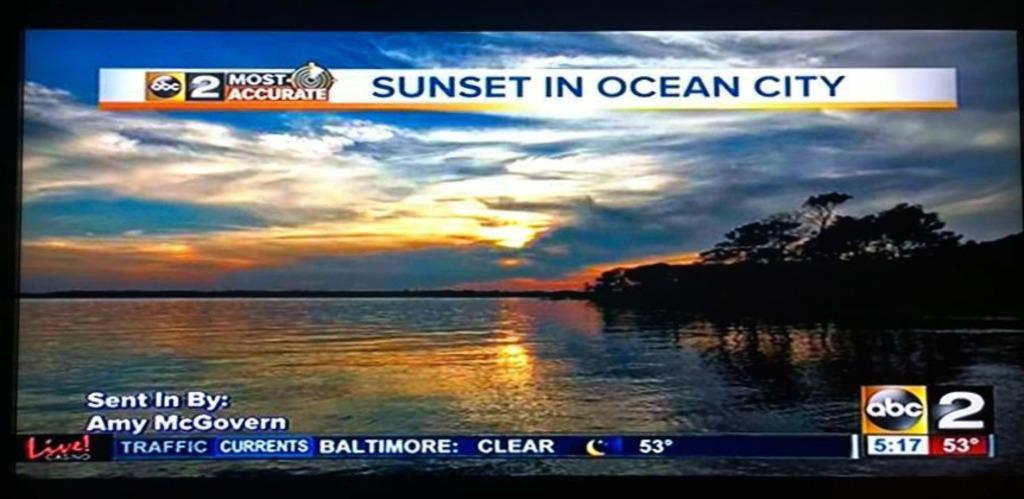What is the network name?
Your answer should be very brief. Abc. What city is being shown?
Your answer should be compact. Ocean city. 